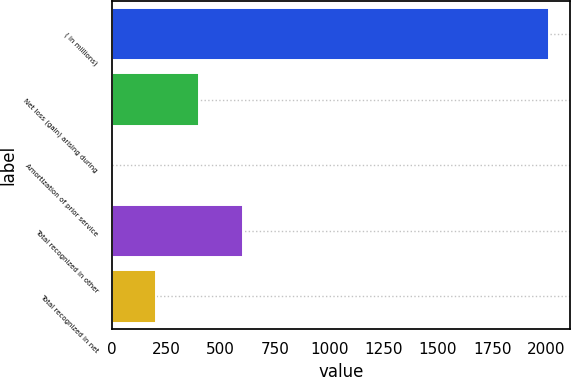<chart> <loc_0><loc_0><loc_500><loc_500><bar_chart><fcel>( in millions)<fcel>Net loss (gain) arising during<fcel>Amortization of prior service<fcel>Total recognized in other<fcel>Total recognized in net<nl><fcel>2010<fcel>402.08<fcel>0.1<fcel>603.07<fcel>201.09<nl></chart> 